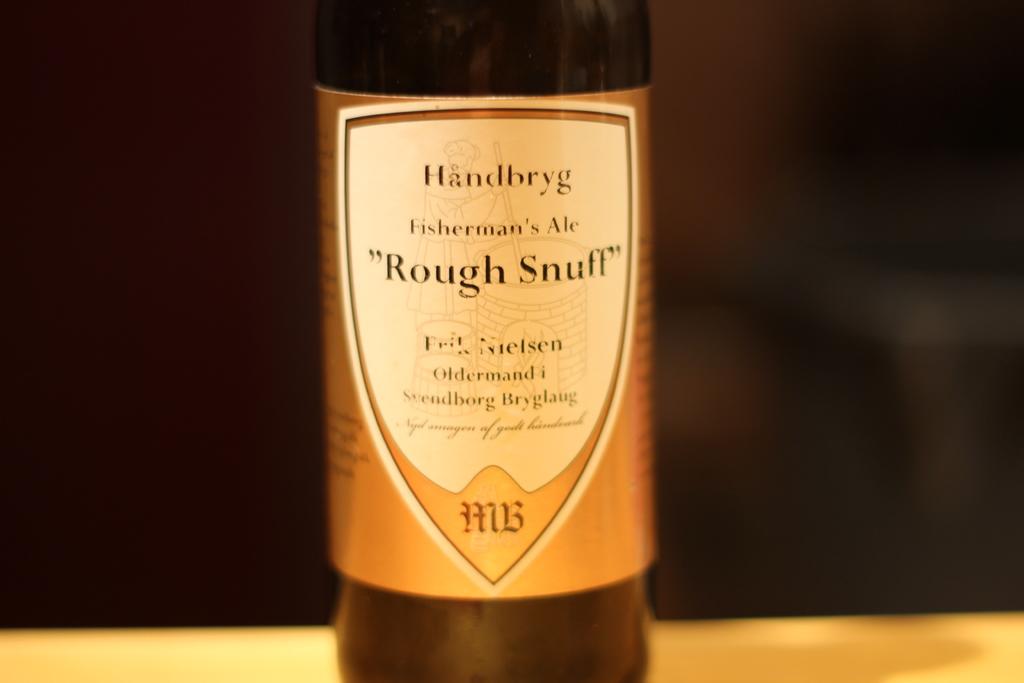What brand of soft drinks?
Offer a very short reply. Handbryg. 